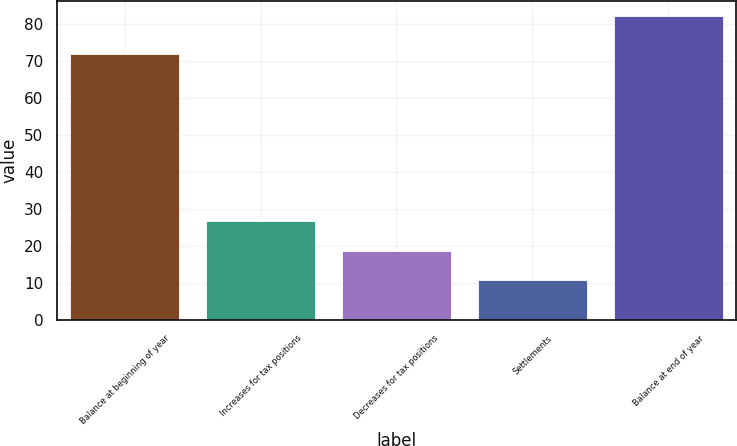Convert chart to OTSL. <chart><loc_0><loc_0><loc_500><loc_500><bar_chart><fcel>Balance at beginning of year<fcel>Increases for tax positions<fcel>Decreases for tax positions<fcel>Settlements<fcel>Balance at end of year<nl><fcel>72<fcel>26.7<fcel>18.8<fcel>10.9<fcel>82<nl></chart> 